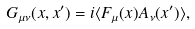Convert formula to latex. <formula><loc_0><loc_0><loc_500><loc_500>G _ { \mu \nu } ( x , x ^ { \prime } ) = i \langle F _ { \mu } ( x ) A _ { \nu } ( x ^ { \prime } ) \rangle ,</formula> 